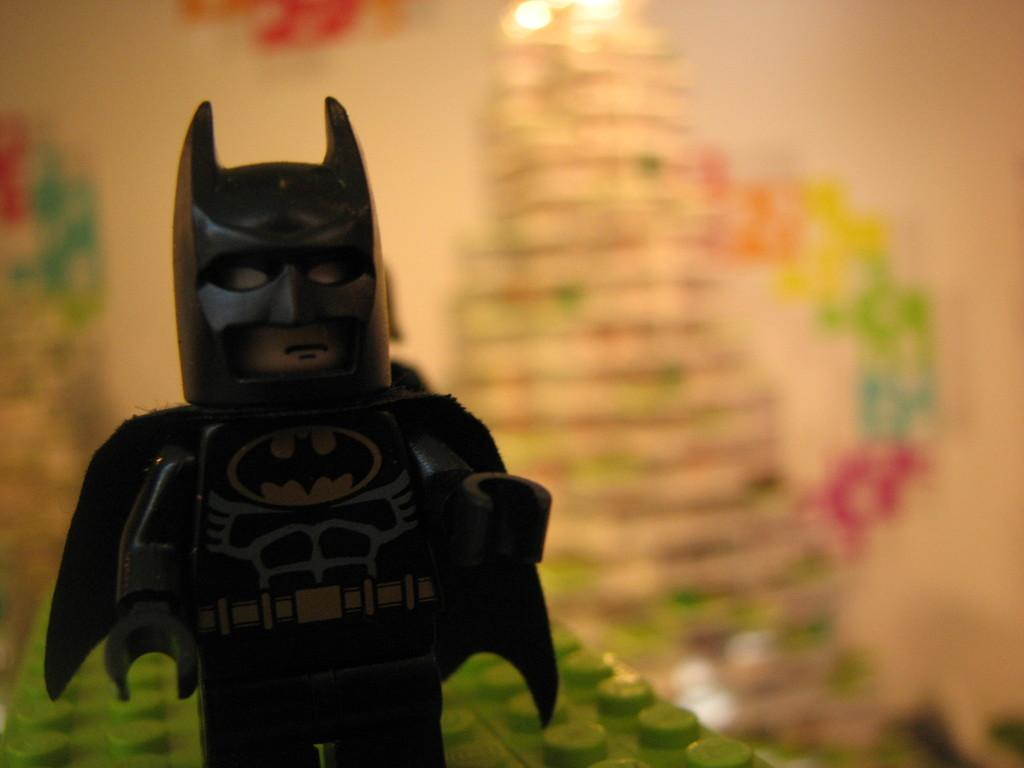What type of toy is in the image? There is a LEGO toy of a Batman in the image. What can be seen in the background of the image? There is a wall in the background of the image. How would you describe the background's appearance? The background appears blurry. What type of egg is visible in the image? There is no egg present in the image. What language is spoken by the LEGO Batman in the image? The LEGO Batman is a toy and does not speak any language. 